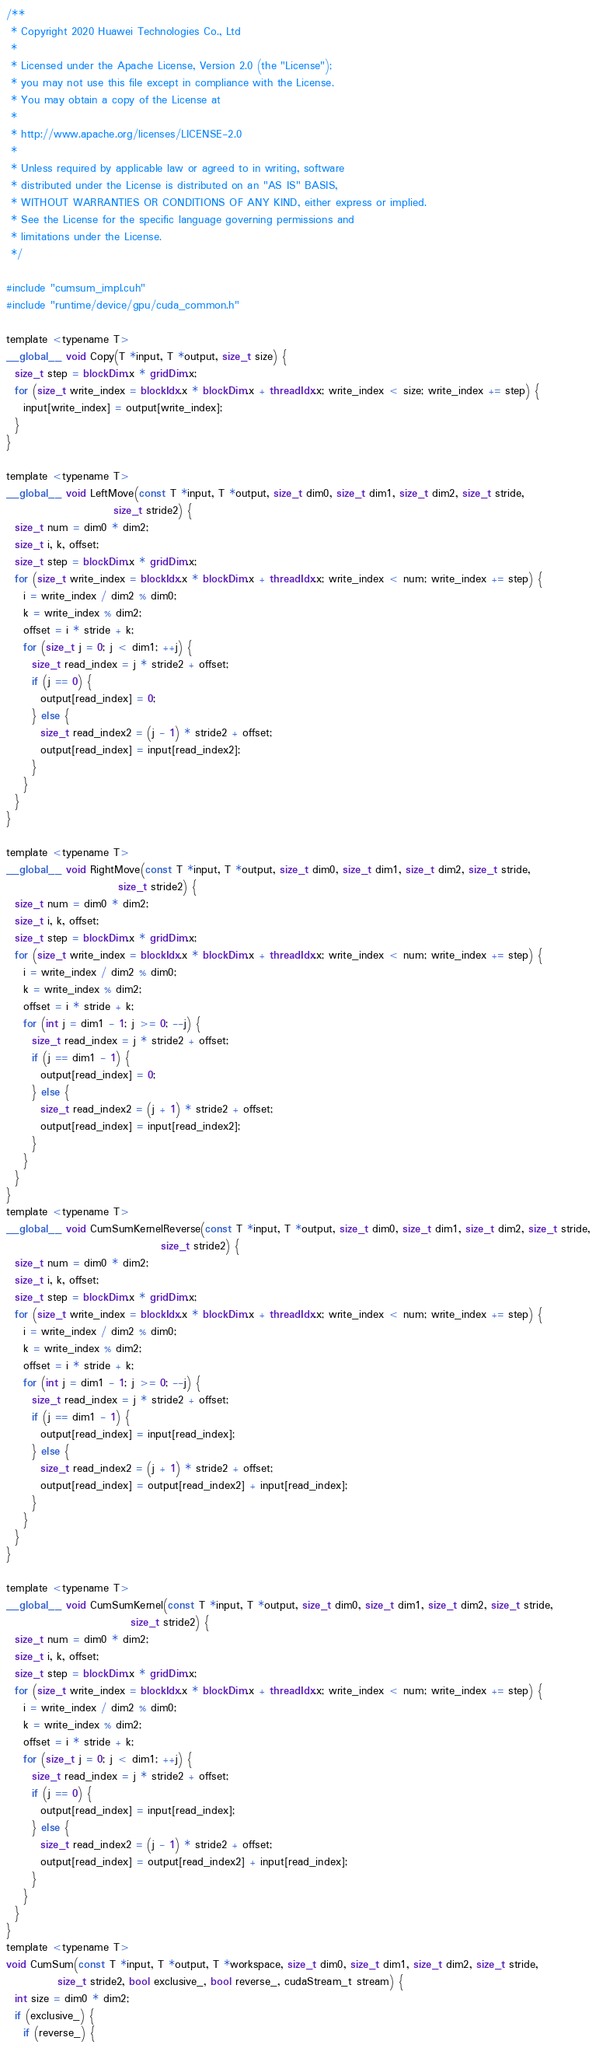<code> <loc_0><loc_0><loc_500><loc_500><_Cuda_>/**
 * Copyright 2020 Huawei Technologies Co., Ltd
 *
 * Licensed under the Apache License, Version 2.0 (the "License");
 * you may not use this file except in compliance with the License.
 * You may obtain a copy of the License at
 *
 * http://www.apache.org/licenses/LICENSE-2.0
 *
 * Unless required by applicable law or agreed to in writing, software
 * distributed under the License is distributed on an "AS IS" BASIS,
 * WITHOUT WARRANTIES OR CONDITIONS OF ANY KIND, either express or implied.
 * See the License for the specific language governing permissions and
 * limitations under the License.
 */

#include "cumsum_impl.cuh"
#include "runtime/device/gpu/cuda_common.h"

template <typename T>
__global__ void Copy(T *input, T *output, size_t size) {
  size_t step = blockDim.x * gridDim.x;
  for (size_t write_index = blockIdx.x * blockDim.x + threadIdx.x; write_index < size; write_index += step) {
    input[write_index] = output[write_index];
  }
}

template <typename T>
__global__ void LeftMove(const T *input, T *output, size_t dim0, size_t dim1, size_t dim2, size_t stride,
                         size_t stride2) {
  size_t num = dim0 * dim2;
  size_t i, k, offset;
  size_t step = blockDim.x * gridDim.x;
  for (size_t write_index = blockIdx.x * blockDim.x + threadIdx.x; write_index < num; write_index += step) {
    i = write_index / dim2 % dim0;
    k = write_index % dim2;
    offset = i * stride + k;
    for (size_t j = 0; j < dim1; ++j) {
      size_t read_index = j * stride2 + offset;
      if (j == 0) {
        output[read_index] = 0;
      } else {
        size_t read_index2 = (j - 1) * stride2 + offset;
        output[read_index] = input[read_index2];
      }
    }
  }
}

template <typename T>
__global__ void RightMove(const T *input, T *output, size_t dim0, size_t dim1, size_t dim2, size_t stride,
                          size_t stride2) {
  size_t num = dim0 * dim2;
  size_t i, k, offset;
  size_t step = blockDim.x * gridDim.x;
  for (size_t write_index = blockIdx.x * blockDim.x + threadIdx.x; write_index < num; write_index += step) {
    i = write_index / dim2 % dim0;
    k = write_index % dim2;
    offset = i * stride + k;
    for (int j = dim1 - 1; j >= 0; --j) {
      size_t read_index = j * stride2 + offset;
      if (j == dim1 - 1) {
        output[read_index] = 0;
      } else {
        size_t read_index2 = (j + 1) * stride2 + offset;
        output[read_index] = input[read_index2];
      }
    }
  }
}
template <typename T>
__global__ void CumSumKernelReverse(const T *input, T *output, size_t dim0, size_t dim1, size_t dim2, size_t stride,
                                    size_t stride2) {
  size_t num = dim0 * dim2;
  size_t i, k, offset;
  size_t step = blockDim.x * gridDim.x;
  for (size_t write_index = blockIdx.x * blockDim.x + threadIdx.x; write_index < num; write_index += step) {
    i = write_index / dim2 % dim0;
    k = write_index % dim2;
    offset = i * stride + k;
    for (int j = dim1 - 1; j >= 0; --j) {
      size_t read_index = j * stride2 + offset;
      if (j == dim1 - 1) {
        output[read_index] = input[read_index];
      } else {
        size_t read_index2 = (j + 1) * stride2 + offset;
        output[read_index] = output[read_index2] + input[read_index];
      }
    }
  }
}

template <typename T>
__global__ void CumSumKernel(const T *input, T *output, size_t dim0, size_t dim1, size_t dim2, size_t stride,
                             size_t stride2) {
  size_t num = dim0 * dim2;
  size_t i, k, offset;
  size_t step = blockDim.x * gridDim.x;
  for (size_t write_index = blockIdx.x * blockDim.x + threadIdx.x; write_index < num; write_index += step) {
    i = write_index / dim2 % dim0;
    k = write_index % dim2;
    offset = i * stride + k;
    for (size_t j = 0; j < dim1; ++j) {
      size_t read_index = j * stride2 + offset;
      if (j == 0) {
        output[read_index] = input[read_index];
      } else {
        size_t read_index2 = (j - 1) * stride2 + offset;
        output[read_index] = output[read_index2] + input[read_index];
      }
    }
  }
}
template <typename T>
void CumSum(const T *input, T *output, T *workspace, size_t dim0, size_t dim1, size_t dim2, size_t stride,
            size_t stride2, bool exclusive_, bool reverse_, cudaStream_t stream) {
  int size = dim0 * dim2;
  if (exclusive_) {
    if (reverse_) {</code> 